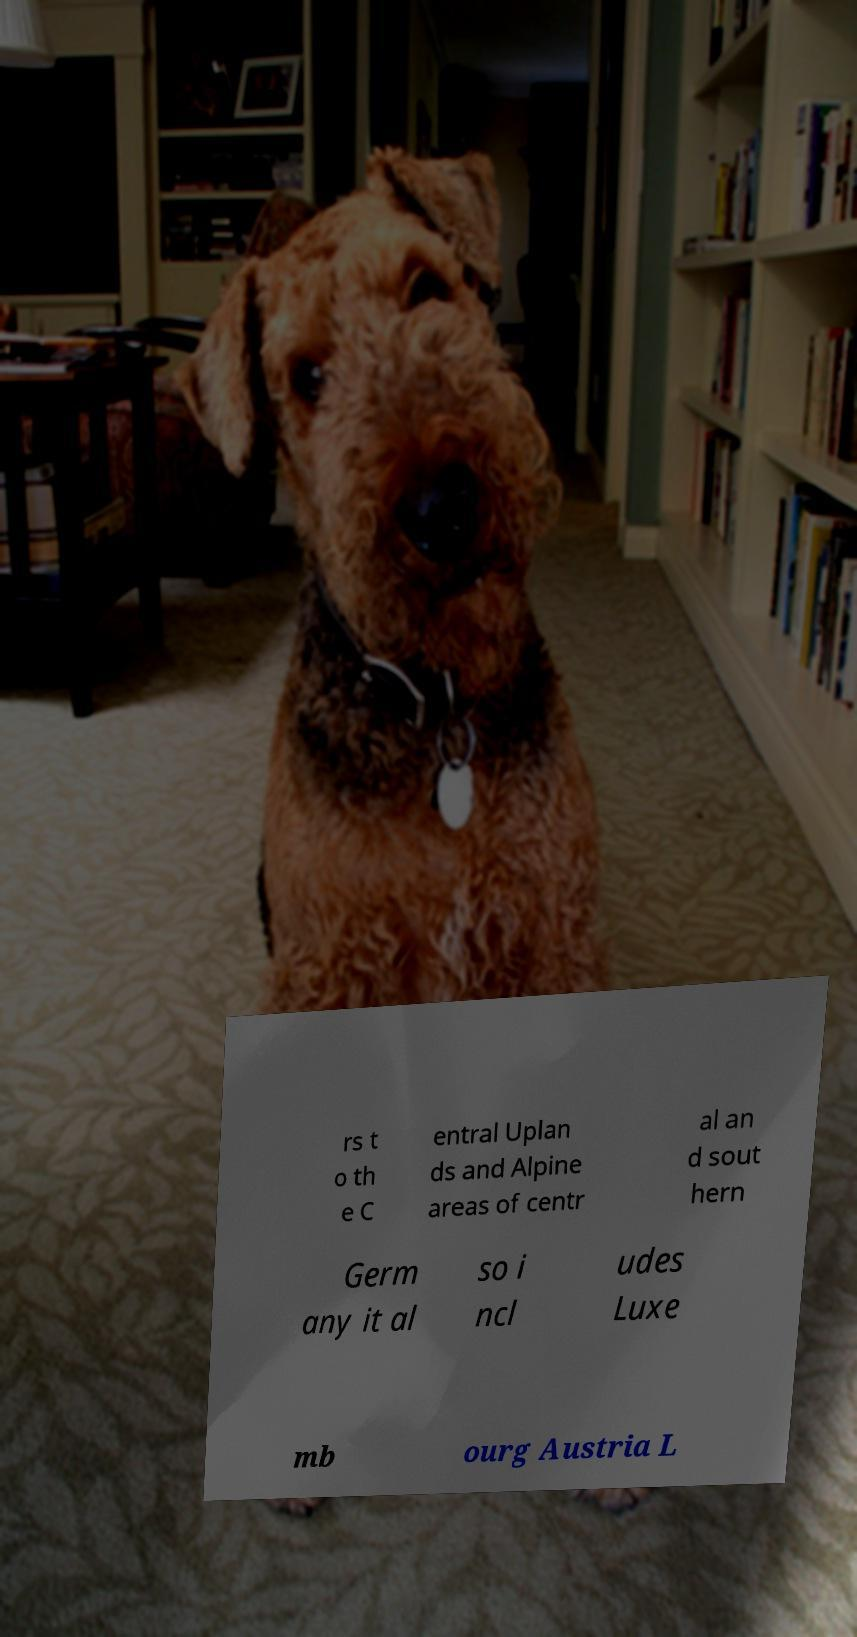There's text embedded in this image that I need extracted. Can you transcribe it verbatim? rs t o th e C entral Uplan ds and Alpine areas of centr al an d sout hern Germ any it al so i ncl udes Luxe mb ourg Austria L 